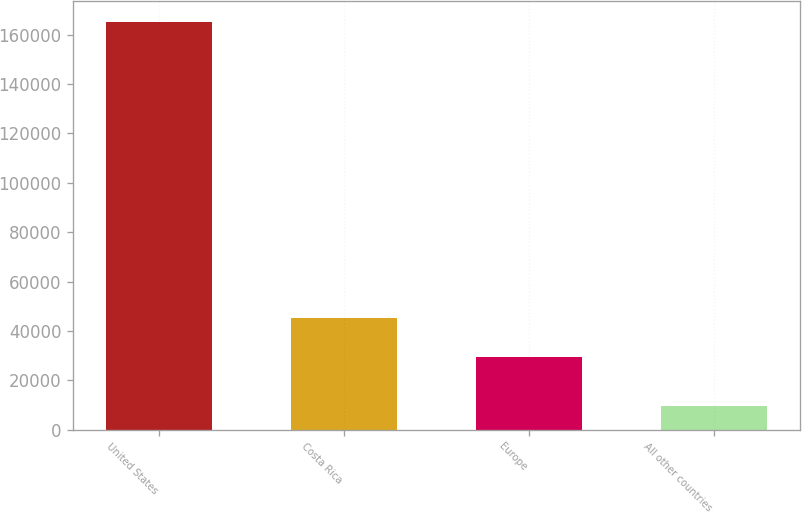Convert chart to OTSL. <chart><loc_0><loc_0><loc_500><loc_500><bar_chart><fcel>United States<fcel>Costa Rica<fcel>Europe<fcel>All other countries<nl><fcel>165177<fcel>45129.6<fcel>29591<fcel>9791<nl></chart> 